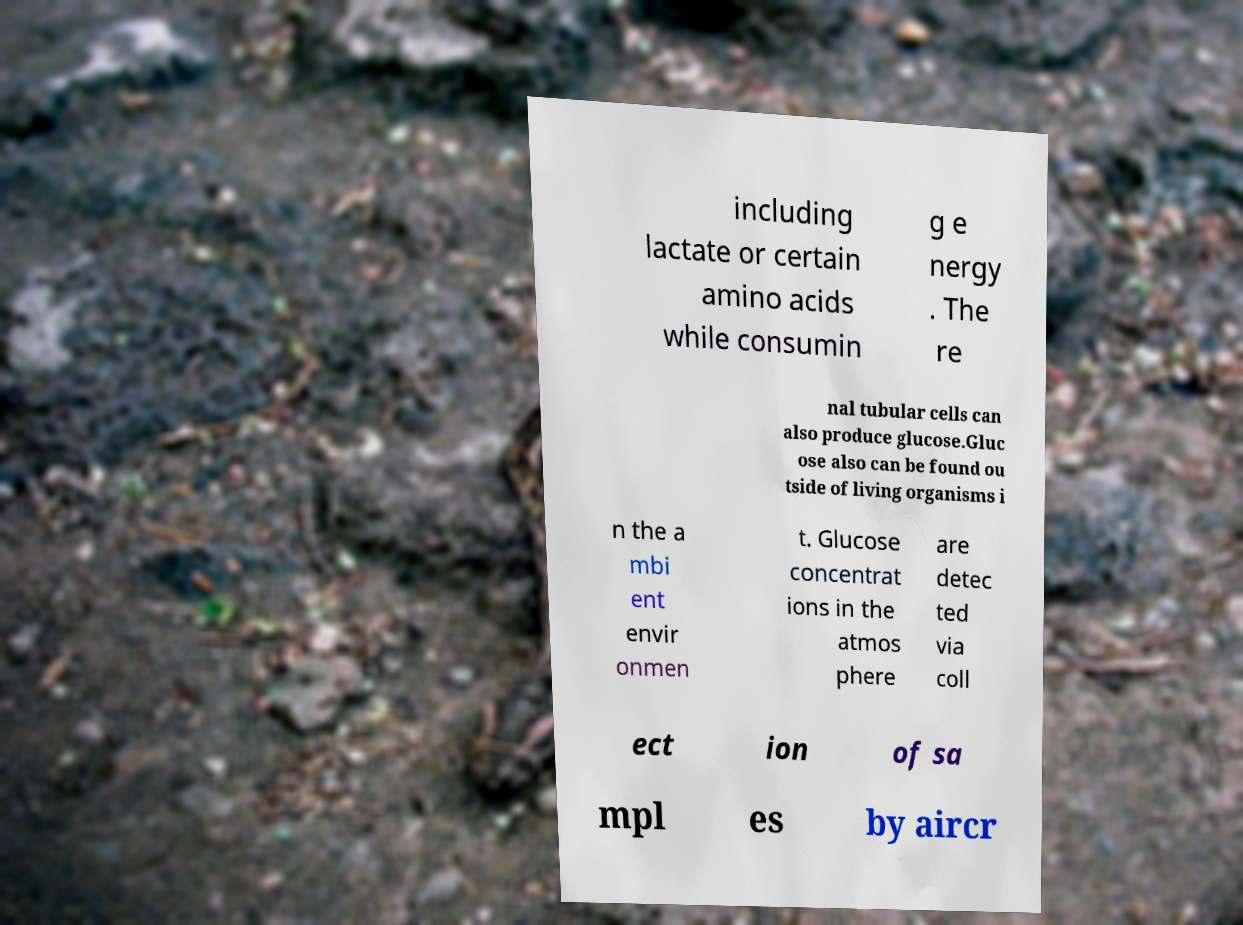I need the written content from this picture converted into text. Can you do that? including lactate or certain amino acids while consumin g e nergy . The re nal tubular cells can also produce glucose.Gluc ose also can be found ou tside of living organisms i n the a mbi ent envir onmen t. Glucose concentrat ions in the atmos phere are detec ted via coll ect ion of sa mpl es by aircr 